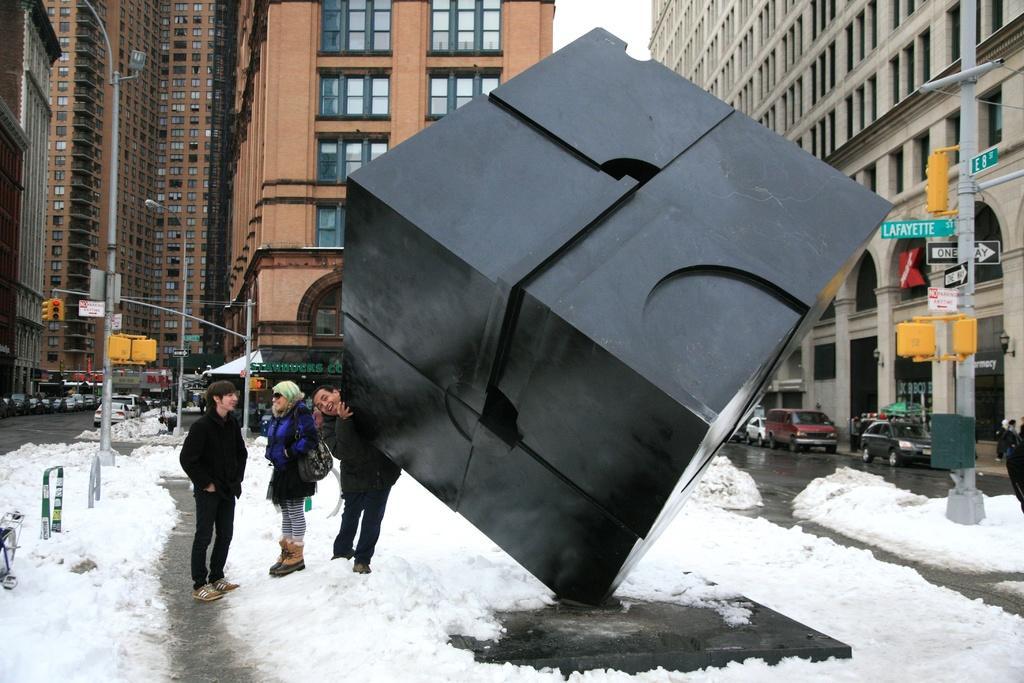How would you summarize this image in a sentence or two? This picture describes about group of people, they are on the ice, in the background we can see few poles, traffic lights, sign boards and vehicles on the road, and also we can see few buildings. 